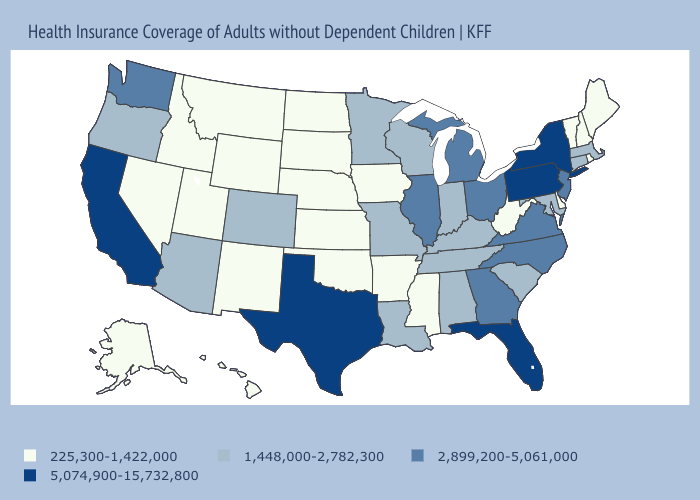What is the highest value in the USA?
Give a very brief answer. 5,074,900-15,732,800. Does Tennessee have the lowest value in the USA?
Be succinct. No. What is the highest value in the USA?
Be succinct. 5,074,900-15,732,800. Name the states that have a value in the range 225,300-1,422,000?
Answer briefly. Alaska, Arkansas, Delaware, Hawaii, Idaho, Iowa, Kansas, Maine, Mississippi, Montana, Nebraska, Nevada, New Hampshire, New Mexico, North Dakota, Oklahoma, Rhode Island, South Dakota, Utah, Vermont, West Virginia, Wyoming. What is the value of Massachusetts?
Give a very brief answer. 1,448,000-2,782,300. Name the states that have a value in the range 2,899,200-5,061,000?
Concise answer only. Georgia, Illinois, Michigan, New Jersey, North Carolina, Ohio, Virginia, Washington. Name the states that have a value in the range 2,899,200-5,061,000?
Concise answer only. Georgia, Illinois, Michigan, New Jersey, North Carolina, Ohio, Virginia, Washington. Name the states that have a value in the range 5,074,900-15,732,800?
Quick response, please. California, Florida, New York, Pennsylvania, Texas. Which states hav the highest value in the MidWest?
Give a very brief answer. Illinois, Michigan, Ohio. Which states have the lowest value in the USA?
Write a very short answer. Alaska, Arkansas, Delaware, Hawaii, Idaho, Iowa, Kansas, Maine, Mississippi, Montana, Nebraska, Nevada, New Hampshire, New Mexico, North Dakota, Oklahoma, Rhode Island, South Dakota, Utah, Vermont, West Virginia, Wyoming. Does Vermont have the lowest value in the USA?
Quick response, please. Yes. What is the highest value in the USA?
Be succinct. 5,074,900-15,732,800. Which states have the lowest value in the West?
Quick response, please. Alaska, Hawaii, Idaho, Montana, Nevada, New Mexico, Utah, Wyoming. What is the highest value in states that border South Dakota?
Short answer required. 1,448,000-2,782,300. What is the value of Tennessee?
Answer briefly. 1,448,000-2,782,300. 